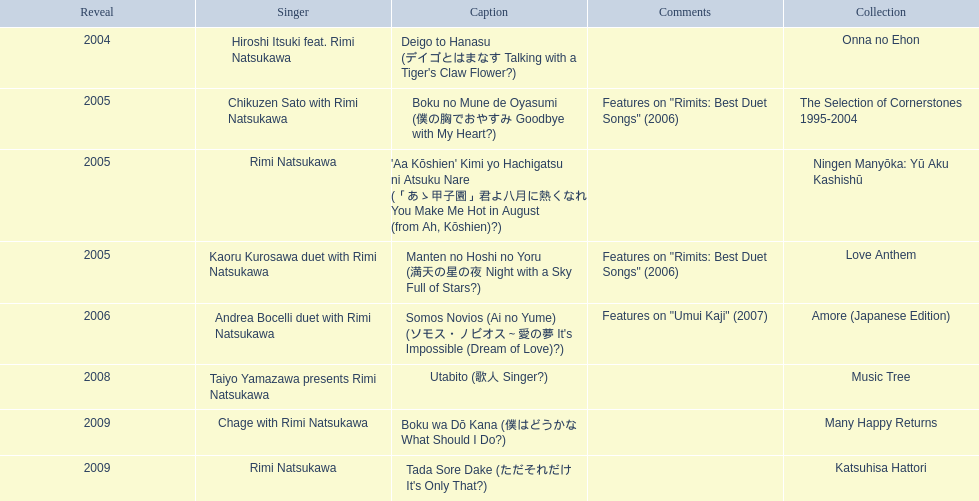Which year had the most titles released? 2005. 